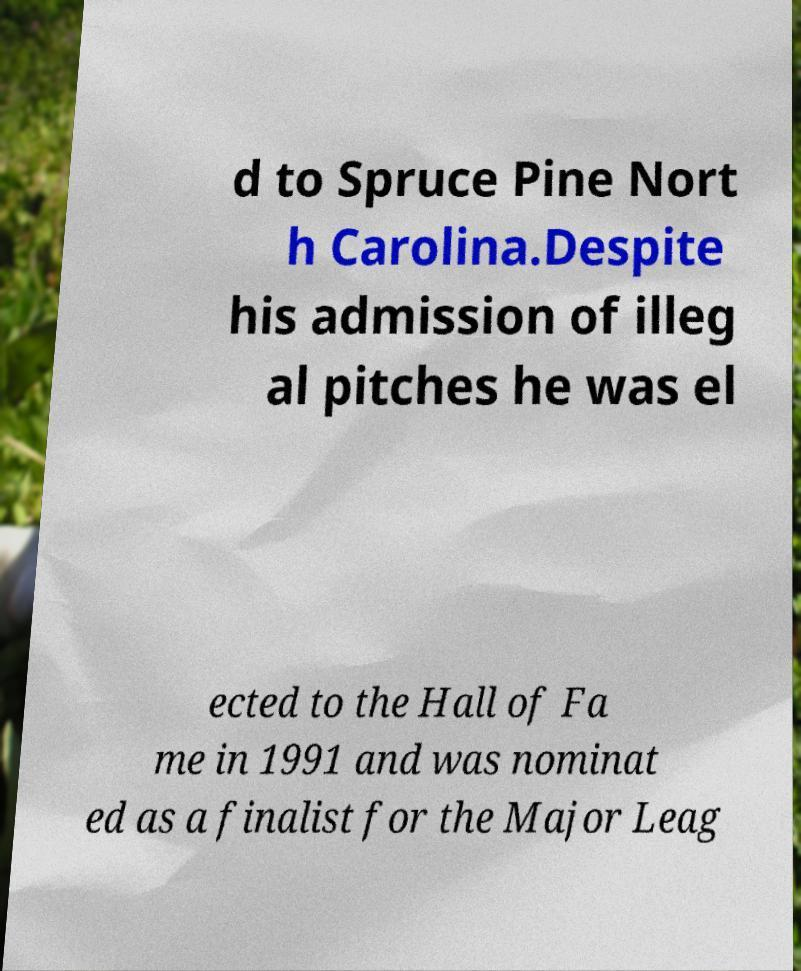Please identify and transcribe the text found in this image. d to Spruce Pine Nort h Carolina.Despite his admission of illeg al pitches he was el ected to the Hall of Fa me in 1991 and was nominat ed as a finalist for the Major Leag 